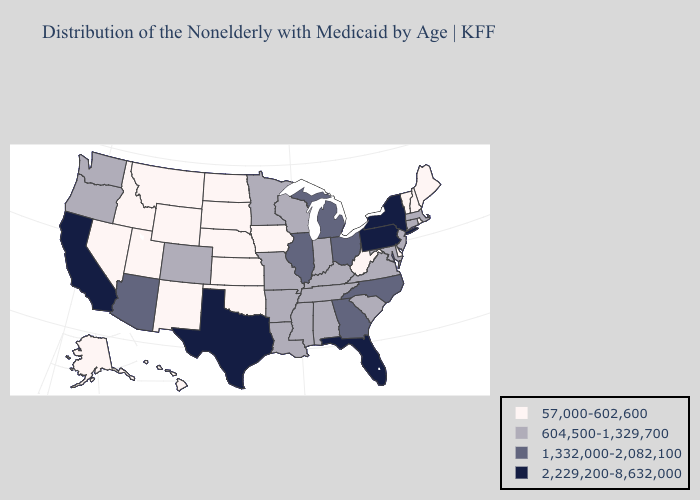Does Nevada have the lowest value in the USA?
Keep it brief. Yes. Does Michigan have a lower value than New Hampshire?
Give a very brief answer. No. Does Alabama have the same value as New York?
Answer briefly. No. Does Florida have the highest value in the USA?
Keep it brief. Yes. Does New Jersey have the same value as Illinois?
Answer briefly. No. Does the first symbol in the legend represent the smallest category?
Give a very brief answer. Yes. What is the value of Florida?
Keep it brief. 2,229,200-8,632,000. Name the states that have a value in the range 2,229,200-8,632,000?
Quick response, please. California, Florida, New York, Pennsylvania, Texas. What is the value of North Dakota?
Be succinct. 57,000-602,600. What is the lowest value in states that border New Jersey?
Concise answer only. 57,000-602,600. What is the value of Idaho?
Write a very short answer. 57,000-602,600. Which states have the lowest value in the MidWest?
Quick response, please. Iowa, Kansas, Nebraska, North Dakota, South Dakota. Does the first symbol in the legend represent the smallest category?
Give a very brief answer. Yes. 